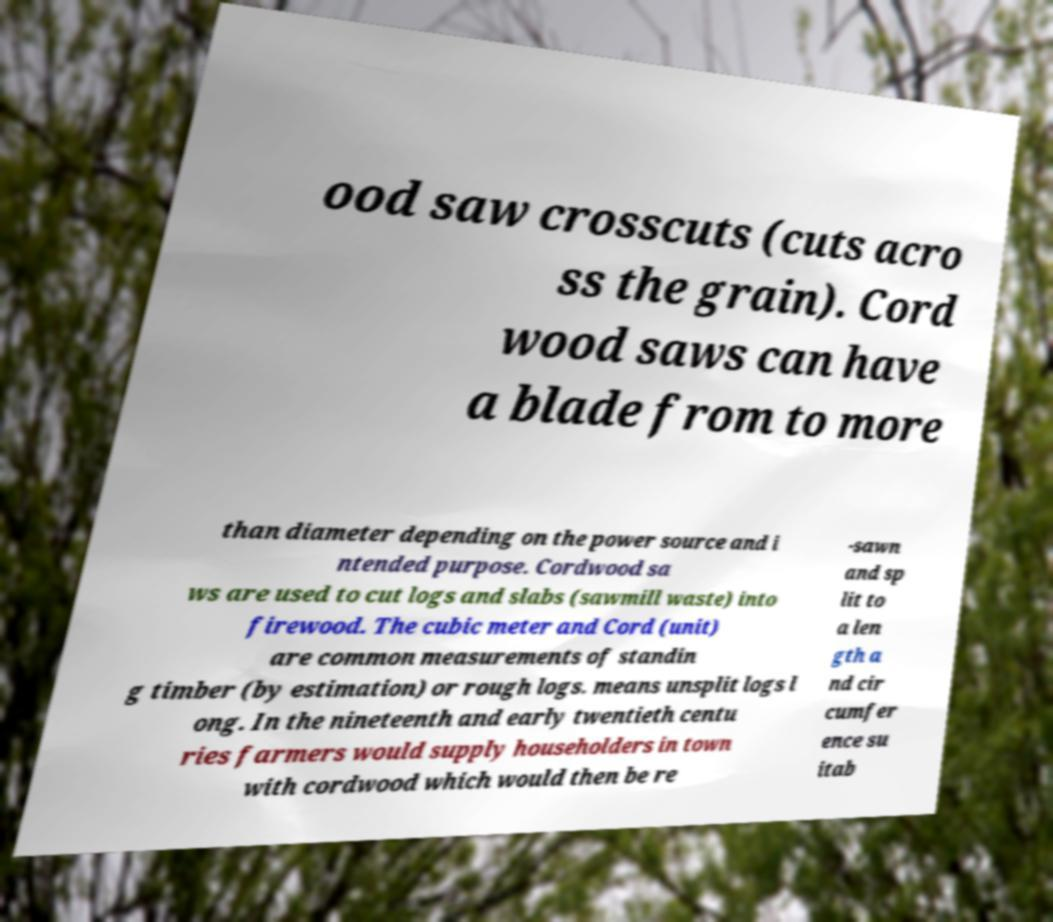There's text embedded in this image that I need extracted. Can you transcribe it verbatim? ood saw crosscuts (cuts acro ss the grain). Cord wood saws can have a blade from to more than diameter depending on the power source and i ntended purpose. Cordwood sa ws are used to cut logs and slabs (sawmill waste) into firewood. The cubic meter and Cord (unit) are common measurements of standin g timber (by estimation) or rough logs. means unsplit logs l ong. In the nineteenth and early twentieth centu ries farmers would supply householders in town with cordwood which would then be re -sawn and sp lit to a len gth a nd cir cumfer ence su itab 